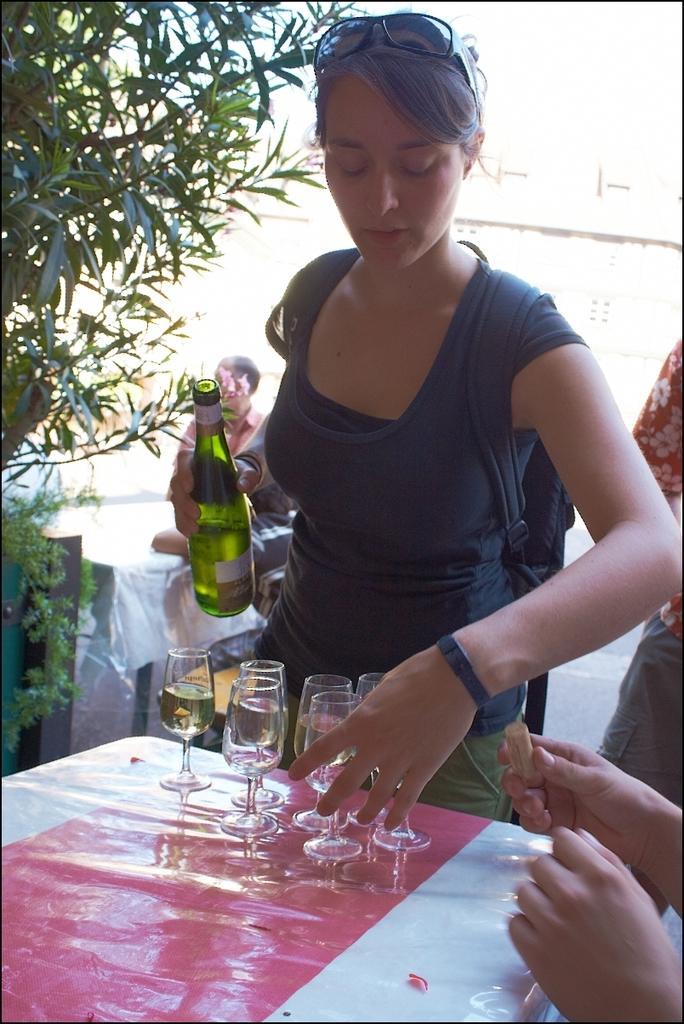In one or two sentences, can you explain what this image depicts? As we can see in the image there is a tree, a woman standing. In front of the women there is a table. On table there are glasses and the woman is holding bottle in her hand. 